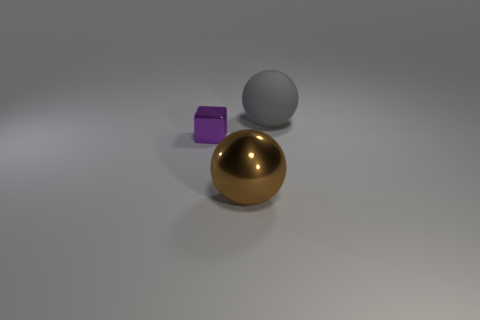Add 2 yellow metallic cylinders. How many objects exist? 5 Subtract all brown balls. How many balls are left? 1 Subtract all red spheres. Subtract all brown blocks. How many spheres are left? 2 Add 3 tiny red cylinders. How many tiny red cylinders exist? 3 Subtract 0 cyan cylinders. How many objects are left? 3 Subtract all balls. How many objects are left? 1 Subtract all green cylinders. How many red cubes are left? 0 Subtract all yellow cubes. Subtract all brown balls. How many objects are left? 2 Add 1 small shiny blocks. How many small shiny blocks are left? 2 